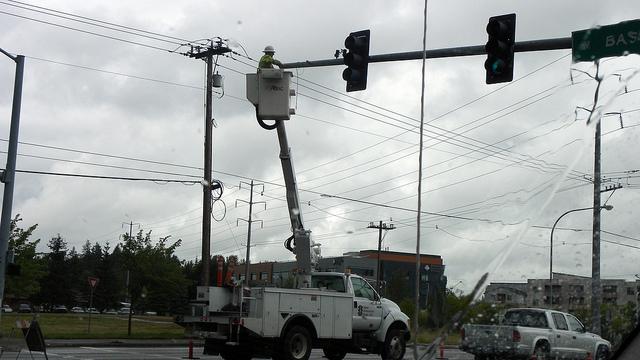What is the man in?
Short answer required. Forklift. How many trucks are there?
Give a very brief answer. 2. How does the traffic look?
Write a very short answer. Light. What are they working on?
Quick response, please. Traffic light. 